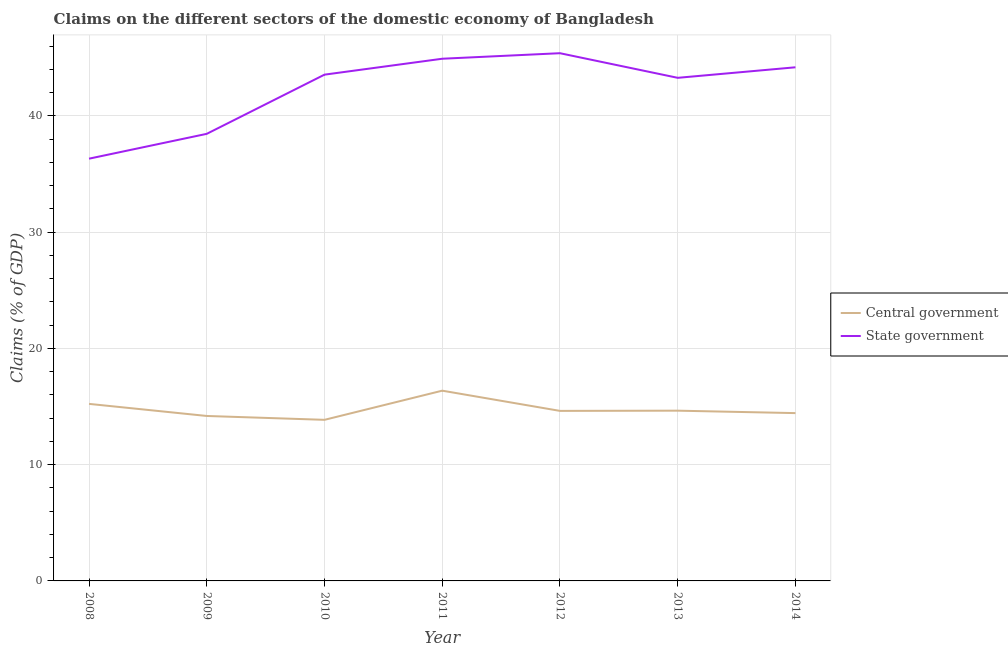How many different coloured lines are there?
Your response must be concise. 2. Is the number of lines equal to the number of legend labels?
Provide a short and direct response. Yes. What is the claims on central government in 2008?
Make the answer very short. 15.23. Across all years, what is the maximum claims on central government?
Your response must be concise. 16.37. Across all years, what is the minimum claims on state government?
Provide a succinct answer. 36.32. In which year was the claims on state government maximum?
Offer a terse response. 2012. What is the total claims on state government in the graph?
Ensure brevity in your answer.  296.11. What is the difference between the claims on state government in 2011 and that in 2012?
Offer a very short reply. -0.48. What is the difference between the claims on central government in 2012 and the claims on state government in 2008?
Offer a very short reply. -21.7. What is the average claims on state government per year?
Offer a very short reply. 42.3. In the year 2008, what is the difference between the claims on central government and claims on state government?
Provide a short and direct response. -21.09. In how many years, is the claims on state government greater than 12 %?
Offer a terse response. 7. What is the ratio of the claims on state government in 2008 to that in 2014?
Offer a very short reply. 0.82. What is the difference between the highest and the second highest claims on central government?
Give a very brief answer. 1.14. What is the difference between the highest and the lowest claims on state government?
Keep it short and to the point. 9.07. Is the claims on state government strictly greater than the claims on central government over the years?
Keep it short and to the point. Yes. How many years are there in the graph?
Offer a very short reply. 7. What is the difference between two consecutive major ticks on the Y-axis?
Make the answer very short. 10. Are the values on the major ticks of Y-axis written in scientific E-notation?
Make the answer very short. No. Does the graph contain any zero values?
Keep it short and to the point. No. Does the graph contain grids?
Keep it short and to the point. Yes. How are the legend labels stacked?
Your response must be concise. Vertical. What is the title of the graph?
Keep it short and to the point. Claims on the different sectors of the domestic economy of Bangladesh. Does "Central government" appear as one of the legend labels in the graph?
Ensure brevity in your answer.  Yes. What is the label or title of the Y-axis?
Your answer should be compact. Claims (% of GDP). What is the Claims (% of GDP) of Central government in 2008?
Provide a succinct answer. 15.23. What is the Claims (% of GDP) in State government in 2008?
Offer a terse response. 36.32. What is the Claims (% of GDP) of Central government in 2009?
Your answer should be compact. 14.19. What is the Claims (% of GDP) of State government in 2009?
Your answer should be very brief. 38.46. What is the Claims (% of GDP) of Central government in 2010?
Give a very brief answer. 13.86. What is the Claims (% of GDP) in State government in 2010?
Offer a terse response. 43.55. What is the Claims (% of GDP) of Central government in 2011?
Your answer should be very brief. 16.37. What is the Claims (% of GDP) in State government in 2011?
Provide a short and direct response. 44.92. What is the Claims (% of GDP) of Central government in 2012?
Your answer should be compact. 14.63. What is the Claims (% of GDP) of State government in 2012?
Your answer should be compact. 45.39. What is the Claims (% of GDP) of Central government in 2013?
Offer a very short reply. 14.65. What is the Claims (% of GDP) of State government in 2013?
Keep it short and to the point. 43.28. What is the Claims (% of GDP) in Central government in 2014?
Keep it short and to the point. 14.44. What is the Claims (% of GDP) of State government in 2014?
Provide a short and direct response. 44.18. Across all years, what is the maximum Claims (% of GDP) of Central government?
Offer a terse response. 16.37. Across all years, what is the maximum Claims (% of GDP) in State government?
Give a very brief answer. 45.39. Across all years, what is the minimum Claims (% of GDP) in Central government?
Give a very brief answer. 13.86. Across all years, what is the minimum Claims (% of GDP) in State government?
Provide a succinct answer. 36.32. What is the total Claims (% of GDP) of Central government in the graph?
Make the answer very short. 103.35. What is the total Claims (% of GDP) of State government in the graph?
Make the answer very short. 296.11. What is the difference between the Claims (% of GDP) in State government in 2008 and that in 2009?
Give a very brief answer. -2.14. What is the difference between the Claims (% of GDP) in Central government in 2008 and that in 2010?
Your answer should be compact. 1.37. What is the difference between the Claims (% of GDP) in State government in 2008 and that in 2010?
Your answer should be compact. -7.23. What is the difference between the Claims (% of GDP) of Central government in 2008 and that in 2011?
Ensure brevity in your answer.  -1.14. What is the difference between the Claims (% of GDP) of State government in 2008 and that in 2011?
Offer a very short reply. -8.6. What is the difference between the Claims (% of GDP) of Central government in 2008 and that in 2012?
Offer a terse response. 0.6. What is the difference between the Claims (% of GDP) in State government in 2008 and that in 2012?
Your answer should be very brief. -9.07. What is the difference between the Claims (% of GDP) of Central government in 2008 and that in 2013?
Provide a short and direct response. 0.58. What is the difference between the Claims (% of GDP) of State government in 2008 and that in 2013?
Your answer should be very brief. -6.95. What is the difference between the Claims (% of GDP) in Central government in 2008 and that in 2014?
Ensure brevity in your answer.  0.79. What is the difference between the Claims (% of GDP) in State government in 2008 and that in 2014?
Offer a very short reply. -7.86. What is the difference between the Claims (% of GDP) of Central government in 2009 and that in 2010?
Keep it short and to the point. 0.33. What is the difference between the Claims (% of GDP) in State government in 2009 and that in 2010?
Your answer should be compact. -5.09. What is the difference between the Claims (% of GDP) of Central government in 2009 and that in 2011?
Offer a terse response. -2.18. What is the difference between the Claims (% of GDP) in State government in 2009 and that in 2011?
Your answer should be very brief. -6.46. What is the difference between the Claims (% of GDP) in Central government in 2009 and that in 2012?
Provide a short and direct response. -0.44. What is the difference between the Claims (% of GDP) of State government in 2009 and that in 2012?
Offer a terse response. -6.94. What is the difference between the Claims (% of GDP) of Central government in 2009 and that in 2013?
Your answer should be compact. -0.46. What is the difference between the Claims (% of GDP) in State government in 2009 and that in 2013?
Your answer should be compact. -4.82. What is the difference between the Claims (% of GDP) of Central government in 2009 and that in 2014?
Provide a short and direct response. -0.25. What is the difference between the Claims (% of GDP) in State government in 2009 and that in 2014?
Provide a short and direct response. -5.72. What is the difference between the Claims (% of GDP) of Central government in 2010 and that in 2011?
Make the answer very short. -2.51. What is the difference between the Claims (% of GDP) in State government in 2010 and that in 2011?
Keep it short and to the point. -1.37. What is the difference between the Claims (% of GDP) in Central government in 2010 and that in 2012?
Offer a terse response. -0.77. What is the difference between the Claims (% of GDP) of State government in 2010 and that in 2012?
Give a very brief answer. -1.84. What is the difference between the Claims (% of GDP) of Central government in 2010 and that in 2013?
Give a very brief answer. -0.79. What is the difference between the Claims (% of GDP) of State government in 2010 and that in 2013?
Offer a very short reply. 0.27. What is the difference between the Claims (% of GDP) in Central government in 2010 and that in 2014?
Keep it short and to the point. -0.58. What is the difference between the Claims (% of GDP) of State government in 2010 and that in 2014?
Keep it short and to the point. -0.63. What is the difference between the Claims (% of GDP) of Central government in 2011 and that in 2012?
Keep it short and to the point. 1.74. What is the difference between the Claims (% of GDP) in State government in 2011 and that in 2012?
Give a very brief answer. -0.48. What is the difference between the Claims (% of GDP) in Central government in 2011 and that in 2013?
Your answer should be very brief. 1.72. What is the difference between the Claims (% of GDP) of State government in 2011 and that in 2013?
Ensure brevity in your answer.  1.64. What is the difference between the Claims (% of GDP) in Central government in 2011 and that in 2014?
Offer a very short reply. 1.93. What is the difference between the Claims (% of GDP) in State government in 2011 and that in 2014?
Offer a terse response. 0.74. What is the difference between the Claims (% of GDP) in Central government in 2012 and that in 2013?
Provide a short and direct response. -0.02. What is the difference between the Claims (% of GDP) in State government in 2012 and that in 2013?
Offer a very short reply. 2.12. What is the difference between the Claims (% of GDP) in Central government in 2012 and that in 2014?
Your answer should be very brief. 0.19. What is the difference between the Claims (% of GDP) of State government in 2012 and that in 2014?
Your answer should be very brief. 1.21. What is the difference between the Claims (% of GDP) of Central government in 2013 and that in 2014?
Your answer should be compact. 0.21. What is the difference between the Claims (% of GDP) of State government in 2013 and that in 2014?
Keep it short and to the point. -0.91. What is the difference between the Claims (% of GDP) of Central government in 2008 and the Claims (% of GDP) of State government in 2009?
Provide a succinct answer. -23.23. What is the difference between the Claims (% of GDP) in Central government in 2008 and the Claims (% of GDP) in State government in 2010?
Your answer should be very brief. -28.32. What is the difference between the Claims (% of GDP) in Central government in 2008 and the Claims (% of GDP) in State government in 2011?
Your answer should be compact. -29.69. What is the difference between the Claims (% of GDP) in Central government in 2008 and the Claims (% of GDP) in State government in 2012?
Offer a very short reply. -30.17. What is the difference between the Claims (% of GDP) of Central government in 2008 and the Claims (% of GDP) of State government in 2013?
Your answer should be compact. -28.05. What is the difference between the Claims (% of GDP) of Central government in 2008 and the Claims (% of GDP) of State government in 2014?
Keep it short and to the point. -28.95. What is the difference between the Claims (% of GDP) in Central government in 2009 and the Claims (% of GDP) in State government in 2010?
Provide a short and direct response. -29.36. What is the difference between the Claims (% of GDP) in Central government in 2009 and the Claims (% of GDP) in State government in 2011?
Offer a terse response. -30.73. What is the difference between the Claims (% of GDP) in Central government in 2009 and the Claims (% of GDP) in State government in 2012?
Your response must be concise. -31.21. What is the difference between the Claims (% of GDP) of Central government in 2009 and the Claims (% of GDP) of State government in 2013?
Give a very brief answer. -29.09. What is the difference between the Claims (% of GDP) of Central government in 2009 and the Claims (% of GDP) of State government in 2014?
Offer a terse response. -29.99. What is the difference between the Claims (% of GDP) of Central government in 2010 and the Claims (% of GDP) of State government in 2011?
Offer a very short reply. -31.06. What is the difference between the Claims (% of GDP) in Central government in 2010 and the Claims (% of GDP) in State government in 2012?
Ensure brevity in your answer.  -31.54. What is the difference between the Claims (% of GDP) in Central government in 2010 and the Claims (% of GDP) in State government in 2013?
Give a very brief answer. -29.42. What is the difference between the Claims (% of GDP) of Central government in 2010 and the Claims (% of GDP) of State government in 2014?
Provide a succinct answer. -30.33. What is the difference between the Claims (% of GDP) of Central government in 2011 and the Claims (% of GDP) of State government in 2012?
Give a very brief answer. -29.03. What is the difference between the Claims (% of GDP) in Central government in 2011 and the Claims (% of GDP) in State government in 2013?
Keep it short and to the point. -26.91. What is the difference between the Claims (% of GDP) in Central government in 2011 and the Claims (% of GDP) in State government in 2014?
Provide a succinct answer. -27.82. What is the difference between the Claims (% of GDP) of Central government in 2012 and the Claims (% of GDP) of State government in 2013?
Provide a short and direct response. -28.65. What is the difference between the Claims (% of GDP) in Central government in 2012 and the Claims (% of GDP) in State government in 2014?
Your response must be concise. -29.56. What is the difference between the Claims (% of GDP) of Central government in 2013 and the Claims (% of GDP) of State government in 2014?
Your answer should be compact. -29.54. What is the average Claims (% of GDP) in Central government per year?
Give a very brief answer. 14.76. What is the average Claims (% of GDP) of State government per year?
Make the answer very short. 42.3. In the year 2008, what is the difference between the Claims (% of GDP) of Central government and Claims (% of GDP) of State government?
Ensure brevity in your answer.  -21.09. In the year 2009, what is the difference between the Claims (% of GDP) of Central government and Claims (% of GDP) of State government?
Ensure brevity in your answer.  -24.27. In the year 2010, what is the difference between the Claims (% of GDP) in Central government and Claims (% of GDP) in State government?
Your answer should be very brief. -29.69. In the year 2011, what is the difference between the Claims (% of GDP) of Central government and Claims (% of GDP) of State government?
Make the answer very short. -28.55. In the year 2012, what is the difference between the Claims (% of GDP) in Central government and Claims (% of GDP) in State government?
Your answer should be compact. -30.77. In the year 2013, what is the difference between the Claims (% of GDP) in Central government and Claims (% of GDP) in State government?
Provide a short and direct response. -28.63. In the year 2014, what is the difference between the Claims (% of GDP) in Central government and Claims (% of GDP) in State government?
Offer a terse response. -29.75. What is the ratio of the Claims (% of GDP) of Central government in 2008 to that in 2009?
Your answer should be compact. 1.07. What is the ratio of the Claims (% of GDP) of State government in 2008 to that in 2009?
Keep it short and to the point. 0.94. What is the ratio of the Claims (% of GDP) in Central government in 2008 to that in 2010?
Offer a very short reply. 1.1. What is the ratio of the Claims (% of GDP) of State government in 2008 to that in 2010?
Your response must be concise. 0.83. What is the ratio of the Claims (% of GDP) in Central government in 2008 to that in 2011?
Your answer should be compact. 0.93. What is the ratio of the Claims (% of GDP) of State government in 2008 to that in 2011?
Ensure brevity in your answer.  0.81. What is the ratio of the Claims (% of GDP) of Central government in 2008 to that in 2012?
Make the answer very short. 1.04. What is the ratio of the Claims (% of GDP) in State government in 2008 to that in 2012?
Your answer should be compact. 0.8. What is the ratio of the Claims (% of GDP) of Central government in 2008 to that in 2013?
Offer a very short reply. 1.04. What is the ratio of the Claims (% of GDP) in State government in 2008 to that in 2013?
Your answer should be very brief. 0.84. What is the ratio of the Claims (% of GDP) of Central government in 2008 to that in 2014?
Give a very brief answer. 1.05. What is the ratio of the Claims (% of GDP) of State government in 2008 to that in 2014?
Keep it short and to the point. 0.82. What is the ratio of the Claims (% of GDP) of Central government in 2009 to that in 2010?
Offer a very short reply. 1.02. What is the ratio of the Claims (% of GDP) of State government in 2009 to that in 2010?
Offer a very short reply. 0.88. What is the ratio of the Claims (% of GDP) in Central government in 2009 to that in 2011?
Give a very brief answer. 0.87. What is the ratio of the Claims (% of GDP) of State government in 2009 to that in 2011?
Keep it short and to the point. 0.86. What is the ratio of the Claims (% of GDP) in Central government in 2009 to that in 2012?
Your answer should be compact. 0.97. What is the ratio of the Claims (% of GDP) of State government in 2009 to that in 2012?
Provide a succinct answer. 0.85. What is the ratio of the Claims (% of GDP) in Central government in 2009 to that in 2013?
Your answer should be compact. 0.97. What is the ratio of the Claims (% of GDP) of State government in 2009 to that in 2013?
Provide a short and direct response. 0.89. What is the ratio of the Claims (% of GDP) of Central government in 2009 to that in 2014?
Your answer should be very brief. 0.98. What is the ratio of the Claims (% of GDP) in State government in 2009 to that in 2014?
Offer a terse response. 0.87. What is the ratio of the Claims (% of GDP) of Central government in 2010 to that in 2011?
Make the answer very short. 0.85. What is the ratio of the Claims (% of GDP) in State government in 2010 to that in 2011?
Offer a very short reply. 0.97. What is the ratio of the Claims (% of GDP) in State government in 2010 to that in 2012?
Give a very brief answer. 0.96. What is the ratio of the Claims (% of GDP) of Central government in 2010 to that in 2013?
Provide a short and direct response. 0.95. What is the ratio of the Claims (% of GDP) in State government in 2010 to that in 2013?
Ensure brevity in your answer.  1.01. What is the ratio of the Claims (% of GDP) in Central government in 2010 to that in 2014?
Your response must be concise. 0.96. What is the ratio of the Claims (% of GDP) in State government in 2010 to that in 2014?
Offer a very short reply. 0.99. What is the ratio of the Claims (% of GDP) of Central government in 2011 to that in 2012?
Provide a short and direct response. 1.12. What is the ratio of the Claims (% of GDP) of State government in 2011 to that in 2012?
Offer a very short reply. 0.99. What is the ratio of the Claims (% of GDP) of Central government in 2011 to that in 2013?
Ensure brevity in your answer.  1.12. What is the ratio of the Claims (% of GDP) in State government in 2011 to that in 2013?
Offer a very short reply. 1.04. What is the ratio of the Claims (% of GDP) in Central government in 2011 to that in 2014?
Keep it short and to the point. 1.13. What is the ratio of the Claims (% of GDP) of State government in 2011 to that in 2014?
Give a very brief answer. 1.02. What is the ratio of the Claims (% of GDP) of Central government in 2012 to that in 2013?
Give a very brief answer. 1. What is the ratio of the Claims (% of GDP) in State government in 2012 to that in 2013?
Your answer should be very brief. 1.05. What is the ratio of the Claims (% of GDP) of Central government in 2012 to that in 2014?
Make the answer very short. 1.01. What is the ratio of the Claims (% of GDP) in State government in 2012 to that in 2014?
Keep it short and to the point. 1.03. What is the ratio of the Claims (% of GDP) of Central government in 2013 to that in 2014?
Offer a very short reply. 1.01. What is the ratio of the Claims (% of GDP) in State government in 2013 to that in 2014?
Keep it short and to the point. 0.98. What is the difference between the highest and the second highest Claims (% of GDP) in Central government?
Your answer should be compact. 1.14. What is the difference between the highest and the second highest Claims (% of GDP) in State government?
Provide a succinct answer. 0.48. What is the difference between the highest and the lowest Claims (% of GDP) of Central government?
Your response must be concise. 2.51. What is the difference between the highest and the lowest Claims (% of GDP) of State government?
Make the answer very short. 9.07. 